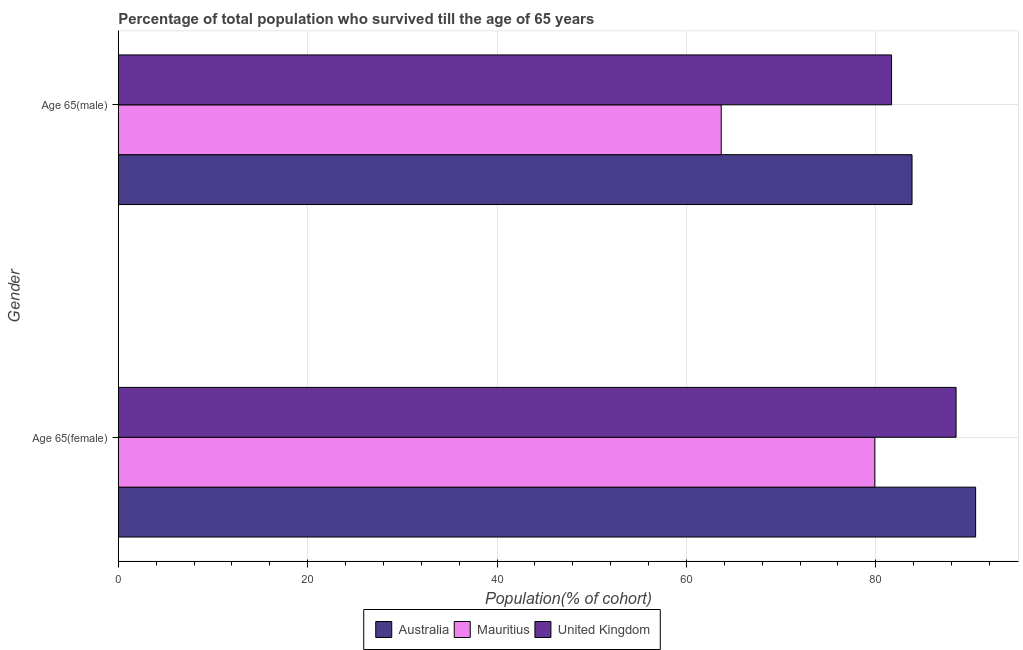How many different coloured bars are there?
Offer a very short reply. 3. How many groups of bars are there?
Keep it short and to the point. 2. How many bars are there on the 2nd tick from the top?
Your answer should be compact. 3. How many bars are there on the 2nd tick from the bottom?
Offer a very short reply. 3. What is the label of the 1st group of bars from the top?
Provide a short and direct response. Age 65(male). What is the percentage of female population who survived till age of 65 in Australia?
Offer a very short reply. 90.54. Across all countries, what is the maximum percentage of female population who survived till age of 65?
Provide a succinct answer. 90.54. Across all countries, what is the minimum percentage of male population who survived till age of 65?
Your answer should be compact. 63.67. In which country was the percentage of male population who survived till age of 65 maximum?
Offer a very short reply. Australia. In which country was the percentage of female population who survived till age of 65 minimum?
Offer a very short reply. Mauritius. What is the total percentage of male population who survived till age of 65 in the graph?
Offer a terse response. 229.16. What is the difference between the percentage of female population who survived till age of 65 in Australia and that in United Kingdom?
Your answer should be compact. 2.06. What is the difference between the percentage of female population who survived till age of 65 in United Kingdom and the percentage of male population who survived till age of 65 in Australia?
Provide a succinct answer. 4.65. What is the average percentage of female population who survived till age of 65 per country?
Keep it short and to the point. 86.3. What is the difference between the percentage of male population who survived till age of 65 and percentage of female population who survived till age of 65 in United Kingdom?
Give a very brief answer. -6.82. In how many countries, is the percentage of male population who survived till age of 65 greater than 76 %?
Make the answer very short. 2. What is the ratio of the percentage of male population who survived till age of 65 in United Kingdom to that in Mauritius?
Offer a terse response. 1.28. Is the percentage of female population who survived till age of 65 in Mauritius less than that in Australia?
Your answer should be very brief. Yes. What does the 1st bar from the top in Age 65(male) represents?
Your response must be concise. United Kingdom. How many bars are there?
Make the answer very short. 6. What is the difference between two consecutive major ticks on the X-axis?
Provide a succinct answer. 20. Are the values on the major ticks of X-axis written in scientific E-notation?
Keep it short and to the point. No. Does the graph contain any zero values?
Provide a short and direct response. No. What is the title of the graph?
Your response must be concise. Percentage of total population who survived till the age of 65 years. What is the label or title of the X-axis?
Your answer should be compact. Population(% of cohort). What is the label or title of the Y-axis?
Your answer should be compact. Gender. What is the Population(% of cohort) in Australia in Age 65(female)?
Make the answer very short. 90.54. What is the Population(% of cohort) in Mauritius in Age 65(female)?
Your answer should be very brief. 79.89. What is the Population(% of cohort) in United Kingdom in Age 65(female)?
Your answer should be compact. 88.48. What is the Population(% of cohort) of Australia in Age 65(male)?
Your answer should be very brief. 83.82. What is the Population(% of cohort) of Mauritius in Age 65(male)?
Offer a terse response. 63.67. What is the Population(% of cohort) in United Kingdom in Age 65(male)?
Ensure brevity in your answer.  81.66. Across all Gender, what is the maximum Population(% of cohort) in Australia?
Your answer should be very brief. 90.54. Across all Gender, what is the maximum Population(% of cohort) in Mauritius?
Your response must be concise. 79.89. Across all Gender, what is the maximum Population(% of cohort) in United Kingdom?
Your answer should be very brief. 88.48. Across all Gender, what is the minimum Population(% of cohort) of Australia?
Give a very brief answer. 83.82. Across all Gender, what is the minimum Population(% of cohort) of Mauritius?
Provide a short and direct response. 63.67. Across all Gender, what is the minimum Population(% of cohort) in United Kingdom?
Give a very brief answer. 81.66. What is the total Population(% of cohort) of Australia in the graph?
Give a very brief answer. 174.36. What is the total Population(% of cohort) in Mauritius in the graph?
Give a very brief answer. 143.56. What is the total Population(% of cohort) in United Kingdom in the graph?
Give a very brief answer. 170.14. What is the difference between the Population(% of cohort) in Australia in Age 65(female) and that in Age 65(male)?
Provide a short and direct response. 6.72. What is the difference between the Population(% of cohort) of Mauritius in Age 65(female) and that in Age 65(male)?
Your answer should be compact. 16.22. What is the difference between the Population(% of cohort) of United Kingdom in Age 65(female) and that in Age 65(male)?
Provide a short and direct response. 6.82. What is the difference between the Population(% of cohort) of Australia in Age 65(female) and the Population(% of cohort) of Mauritius in Age 65(male)?
Provide a succinct answer. 26.87. What is the difference between the Population(% of cohort) in Australia in Age 65(female) and the Population(% of cohort) in United Kingdom in Age 65(male)?
Make the answer very short. 8.88. What is the difference between the Population(% of cohort) in Mauritius in Age 65(female) and the Population(% of cohort) in United Kingdom in Age 65(male)?
Keep it short and to the point. -1.77. What is the average Population(% of cohort) in Australia per Gender?
Provide a succinct answer. 87.18. What is the average Population(% of cohort) of Mauritius per Gender?
Offer a very short reply. 71.78. What is the average Population(% of cohort) of United Kingdom per Gender?
Give a very brief answer. 85.07. What is the difference between the Population(% of cohort) in Australia and Population(% of cohort) in Mauritius in Age 65(female)?
Offer a very short reply. 10.65. What is the difference between the Population(% of cohort) in Australia and Population(% of cohort) in United Kingdom in Age 65(female)?
Your response must be concise. 2.06. What is the difference between the Population(% of cohort) in Mauritius and Population(% of cohort) in United Kingdom in Age 65(female)?
Make the answer very short. -8.59. What is the difference between the Population(% of cohort) of Australia and Population(% of cohort) of Mauritius in Age 65(male)?
Ensure brevity in your answer.  20.15. What is the difference between the Population(% of cohort) in Australia and Population(% of cohort) in United Kingdom in Age 65(male)?
Offer a very short reply. 2.16. What is the difference between the Population(% of cohort) in Mauritius and Population(% of cohort) in United Kingdom in Age 65(male)?
Ensure brevity in your answer.  -17.99. What is the ratio of the Population(% of cohort) in Australia in Age 65(female) to that in Age 65(male)?
Your response must be concise. 1.08. What is the ratio of the Population(% of cohort) of Mauritius in Age 65(female) to that in Age 65(male)?
Your answer should be compact. 1.25. What is the ratio of the Population(% of cohort) of United Kingdom in Age 65(female) to that in Age 65(male)?
Provide a succinct answer. 1.08. What is the difference between the highest and the second highest Population(% of cohort) of Australia?
Offer a terse response. 6.72. What is the difference between the highest and the second highest Population(% of cohort) of Mauritius?
Offer a very short reply. 16.22. What is the difference between the highest and the second highest Population(% of cohort) in United Kingdom?
Your answer should be compact. 6.82. What is the difference between the highest and the lowest Population(% of cohort) of Australia?
Make the answer very short. 6.72. What is the difference between the highest and the lowest Population(% of cohort) of Mauritius?
Give a very brief answer. 16.22. What is the difference between the highest and the lowest Population(% of cohort) in United Kingdom?
Provide a short and direct response. 6.82. 